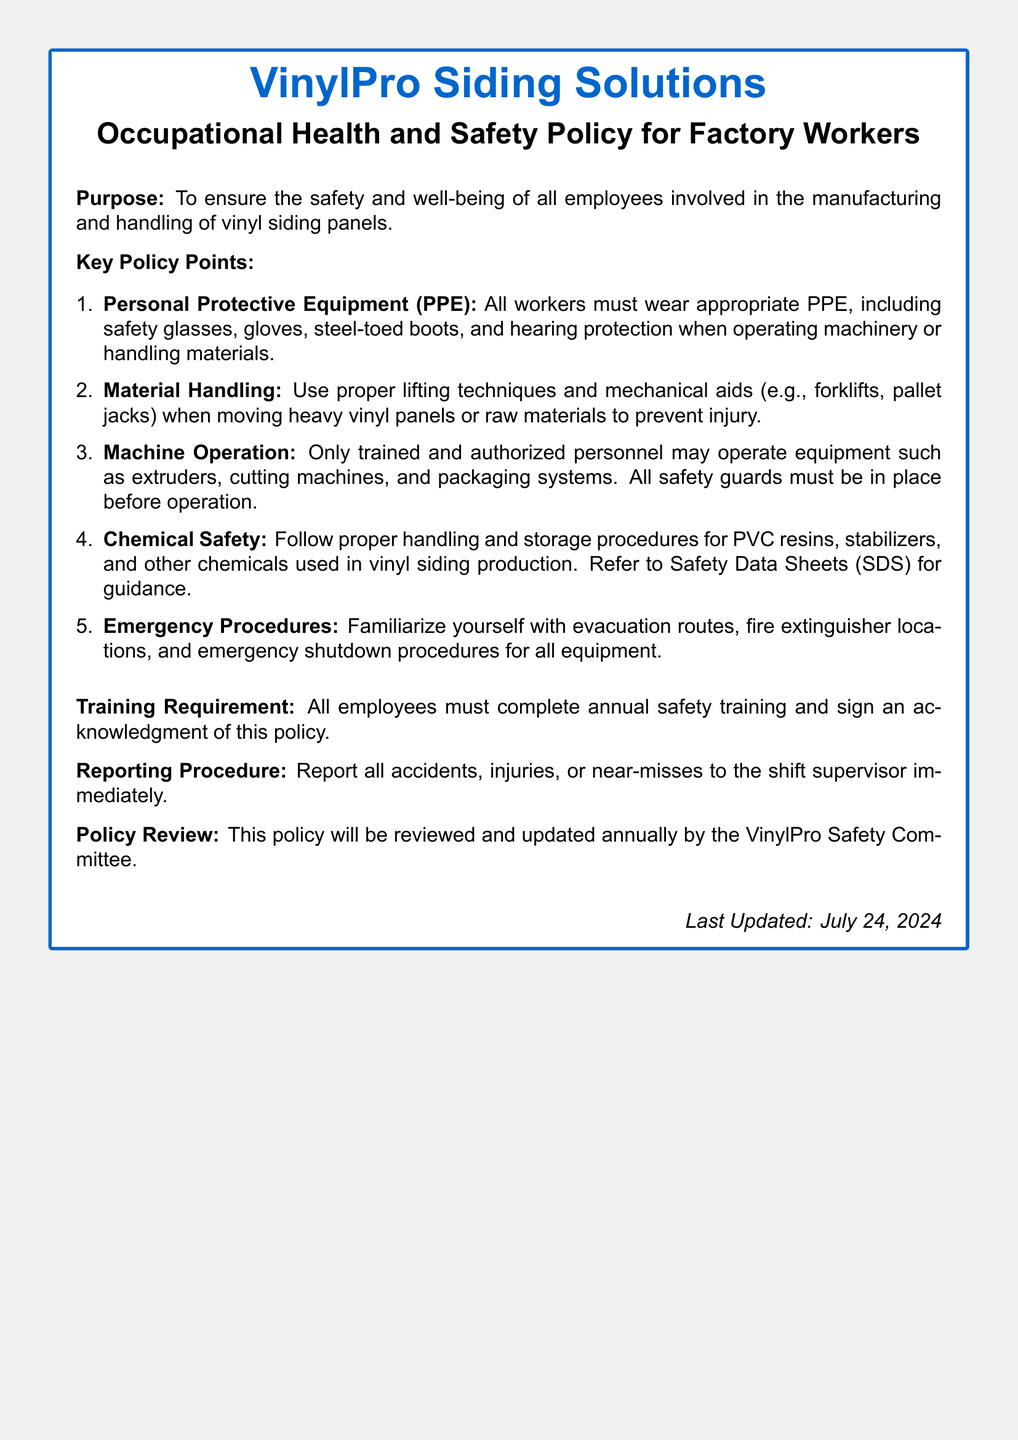What is the purpose of the policy? The purpose is to ensure the safety and well-being of all employees involved in the manufacturing and handling of vinyl siding panels.
Answer: Safety and well-being What protective equipment must workers wear? The policy specifies that workers must wear safety glasses, gloves, steel-toed boots, and hearing protection.
Answer: PPE: safety glasses, gloves, steel-toed boots, hearing protection Who is authorized to operate machinery? Only trained and authorized personnel may operate machinery according to the policy.
Answer: Trained and authorized personnel What must be done before operating equipment? The policy states that all safety guards must be in place before operation.
Answer: Safety guards in place What kind of training is required annually? All employees must complete annual safety training, as mentioned in the document.
Answer: Safety training What chemical safety procedure must be followed? Workers must follow proper handling and storage procedures for chemicals used in production.
Answer: Handling and storage procedures What should you do if an accident occurs? The document states that all accidents, injuries, or near-misses must be reported to the shift supervisor immediately.
Answer: Report to shift supervisor When will the policy be reviewed? The policy will be reviewed and updated annually by the VinylPro Safety Committee.
Answer: Annually by Safety Committee 